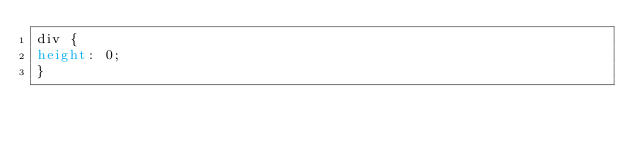<code> <loc_0><loc_0><loc_500><loc_500><_CSS_>div {
height: 0;
}
</code> 